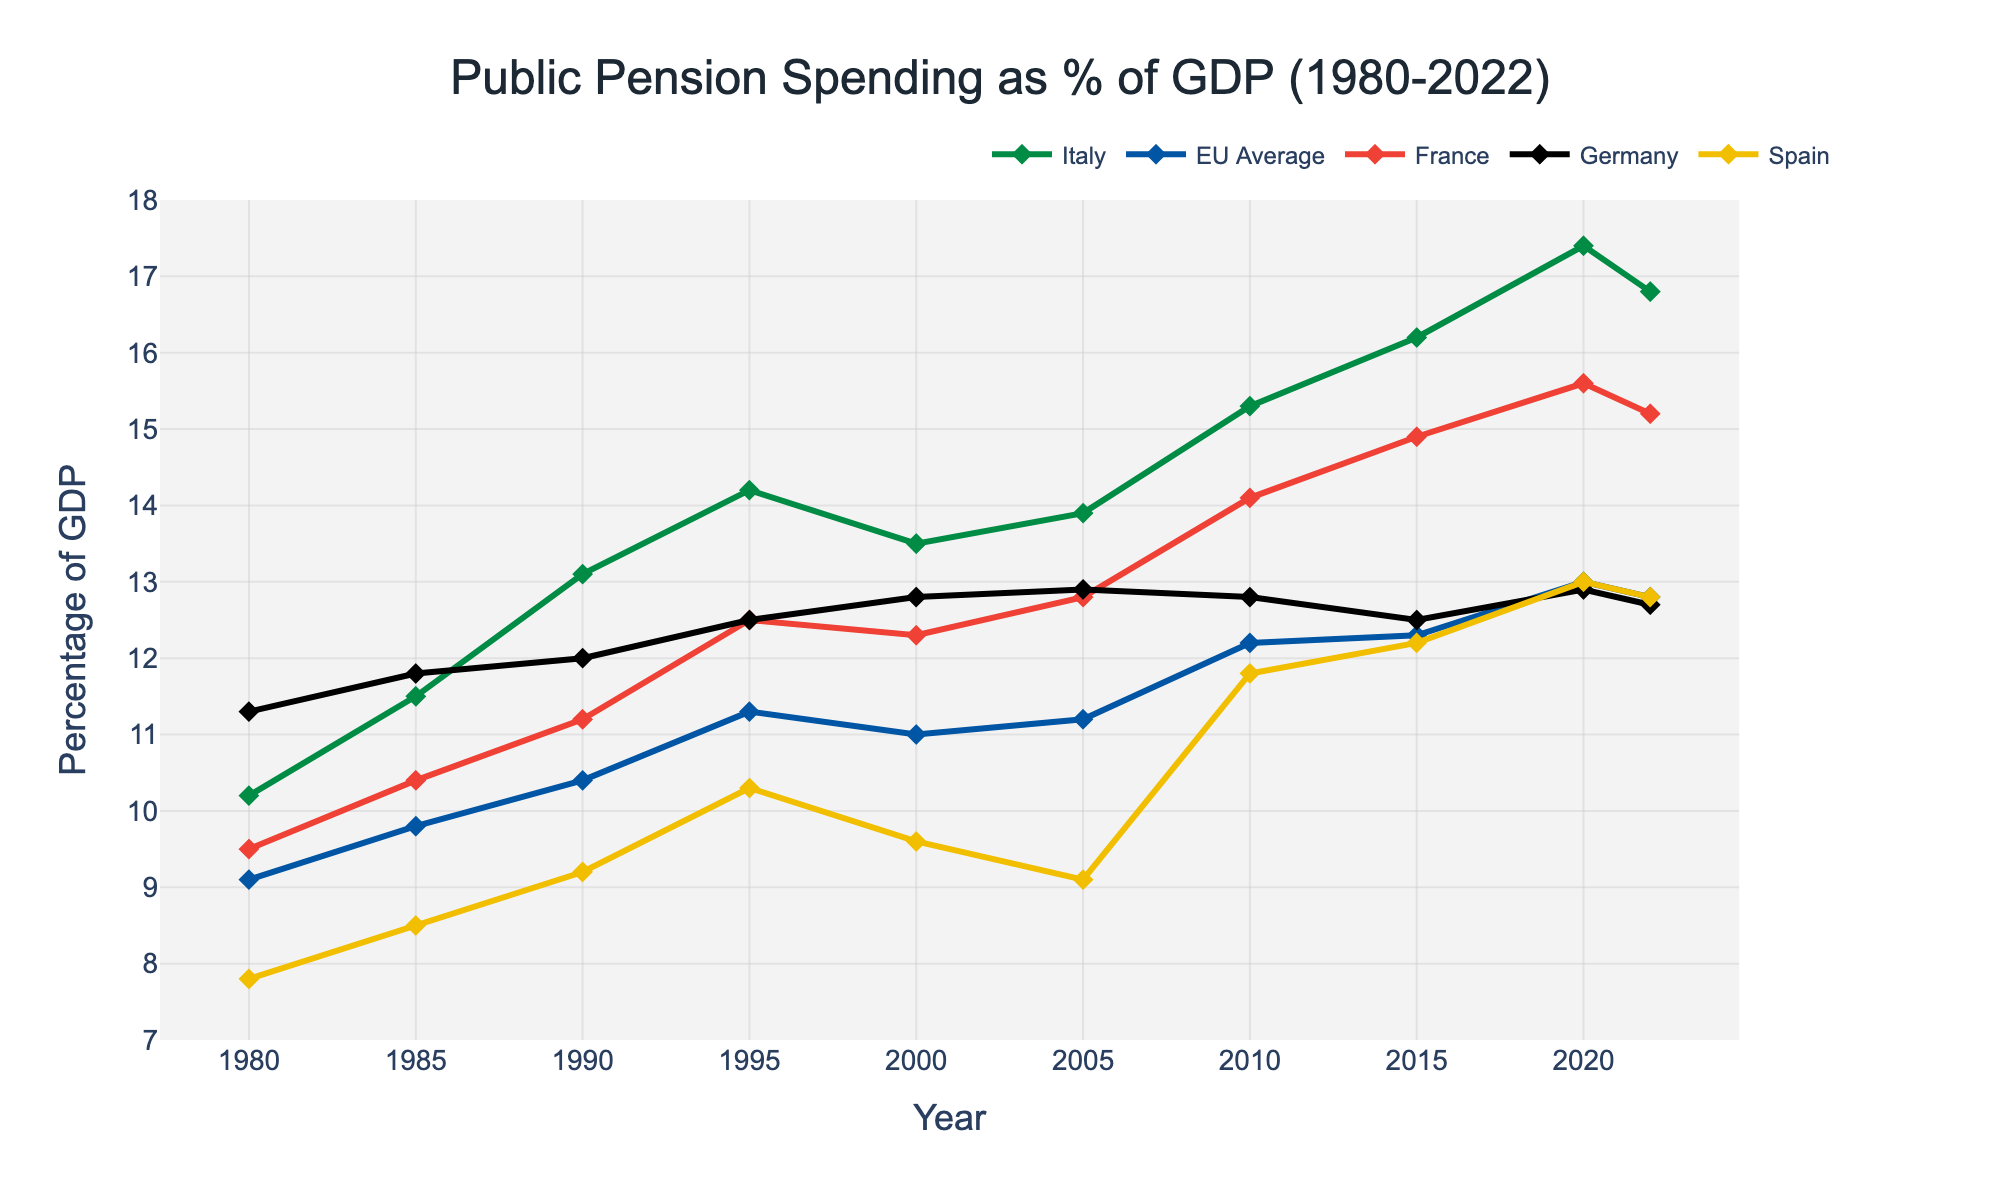What trend can be observed in Italy's public pension spending as a percentage of GDP from 1980 to 2022? The figure shows a general upward trend in Italy's public pension spending as a percentage of GDP from around 10.2% in 1980 to about 16.8% in 2022, with some fluctuations. This indicates an increasing burden of pension spending on Italy’s economy over the years.
Answer: Increasing trend with fluctuations How does Italy's pension spending as a percentage of GDP in 2022 compare to the EU Average? In 2022, Italy's public pension spending was about 16.8% of GDP, while the EU Average was around 12.8%. The difference is 16.8% - 12.8% = 4%.
Answer: 4% more Which country had the highest public pension spending as a percentage of GDP in 2020, and approximately by how much? In 2020, Italy had the highest public pension spending at approximately 17.4% of GDP, while the next highest was France at approximately 15.6%. The difference is 17.4% - 15.6% = 1.8%.
Answer: Italy, by 1.8% Between which years did Italy see the most significant increase in public pension spending as a percentage of GDP? The most significant increase in Italy's public pension spending occurred between 2005 and 2010, where it rose from 13.9% to 15.3%. The increase is 15.3% - 13.9% = 1.4%.
Answer: 2005 to 2010 In which year did Germany's public pension spending as a percentage of GDP peak, and what was the value? Germany's public pension spending as a percentage of GDP peaked around 2005 and 2010, with values approximately 12.9% both years.
Answer: 2005 and 2010, 12.9% How did Spain's public pension spending as a percentage of GDP change from 1980 to 2022? Spain's public pension spending increased from around 7.8% in 1980 to about 12.8% in 2022. The percentage points increase is 12.8% - 7.8% = 5%.
Answer: Increased by 5% Which country had the smallest increase in public pension spending as a percentage of GDP from 1980 to 2022, and what was that increase? Among the given countries, Germany had the smallest increase, from 11.3% in 1980 to 12.7% in 2022. The increase is 12.7% - 11.3% = 1.4%.
Answer: Germany, 1.4% What change can be observed in the EU Average pension spending as a percentage of GDP between 2000 and 2020? The EU Average increased from about 11.0% in 2000 to approximately 13.0% in 2020. The difference is 13.0% - 11.0% = 2%.
Answer: Increased by 2% If the current trend continues, can we expect Italy’s public pension spending percentage to rise or fall in the next decade? Given the historical trend, if the fluctuations continue with the recent slight decline seen in 2022, a precise prediction would indicate a potential stable range around current values rather than a consistent rise or fall.
Answer: Likely stable around current values 